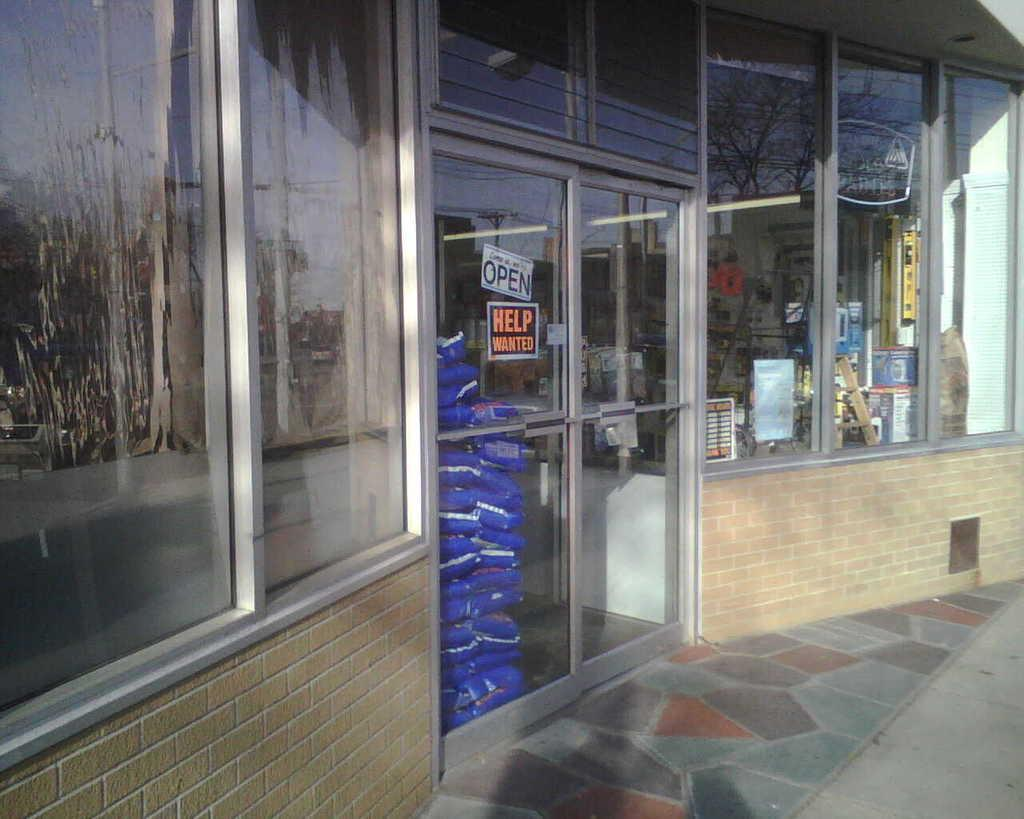<image>
Offer a succinct explanation of the picture presented. A HELP WANTED sign can be seen in the window of a store 